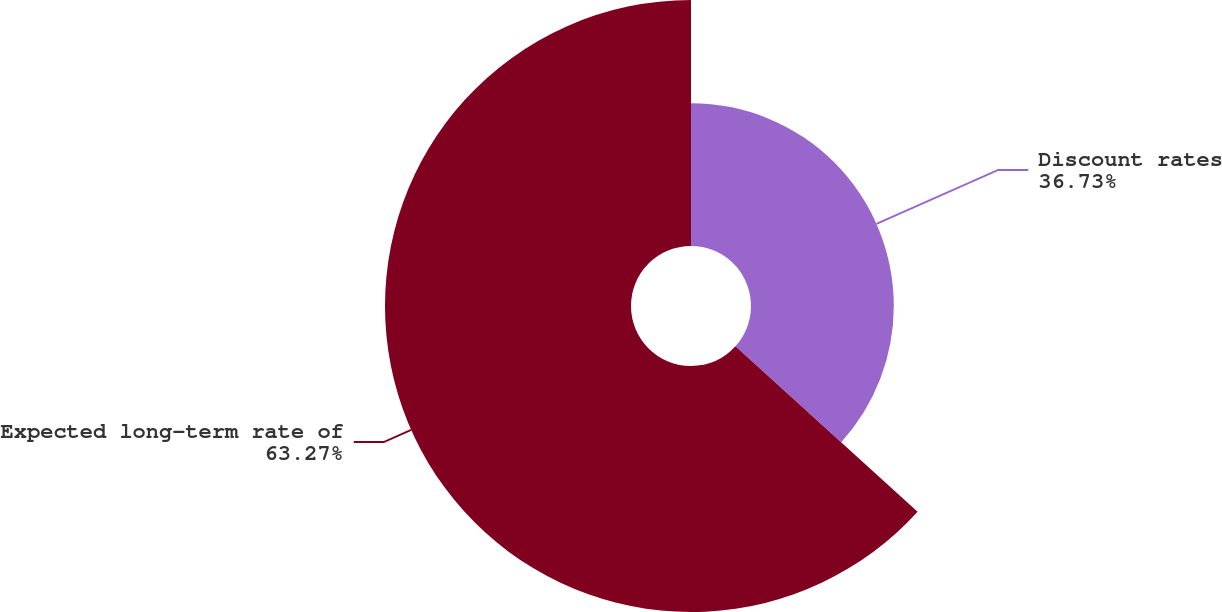Convert chart. <chart><loc_0><loc_0><loc_500><loc_500><pie_chart><fcel>Discount rates<fcel>Expected long-term rate of<nl><fcel>36.73%<fcel>63.27%<nl></chart> 